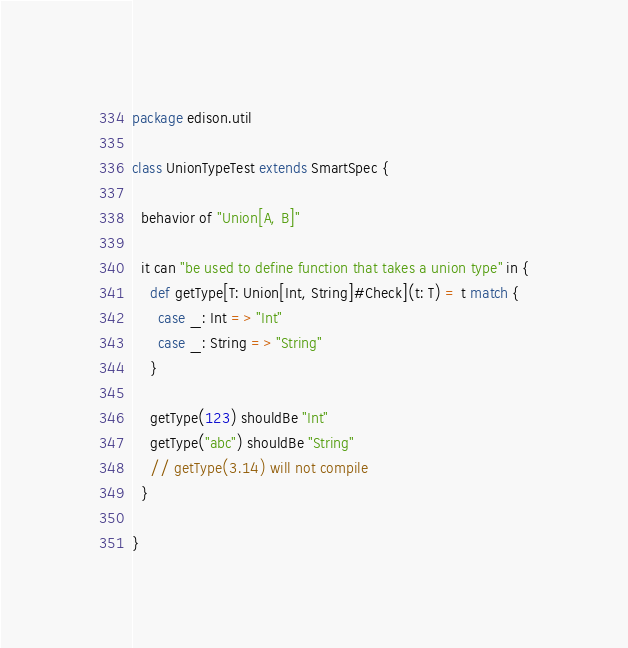<code> <loc_0><loc_0><loc_500><loc_500><_Scala_>package edison.util

class UnionTypeTest extends SmartSpec {

  behavior of "Union[A, B]"

  it can "be used to define function that takes a union type" in {
    def getType[T: Union[Int, String]#Check](t: T) = t match {
      case _: Int => "Int"
      case _: String => "String"
    }

    getType(123) shouldBe "Int"
    getType("abc") shouldBe "String"
    // getType(3.14) will not compile
  }

}
</code> 